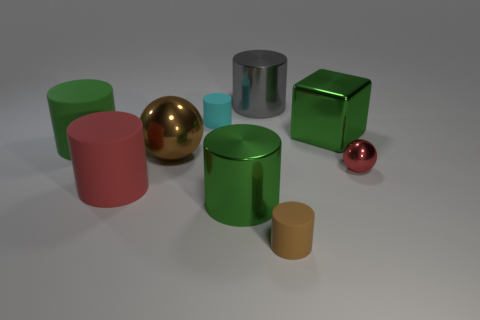Subtract all brown matte cylinders. How many cylinders are left? 5 Subtract all brown blocks. How many green cylinders are left? 2 Subtract 1 blocks. How many blocks are left? 0 Subtract all red balls. How many balls are left? 1 Subtract 0 cyan balls. How many objects are left? 9 Subtract all blocks. How many objects are left? 8 Subtract all green spheres. Subtract all gray blocks. How many spheres are left? 2 Subtract all cyan matte objects. Subtract all large green things. How many objects are left? 5 Add 2 metal spheres. How many metal spheres are left? 4 Add 3 big objects. How many big objects exist? 9 